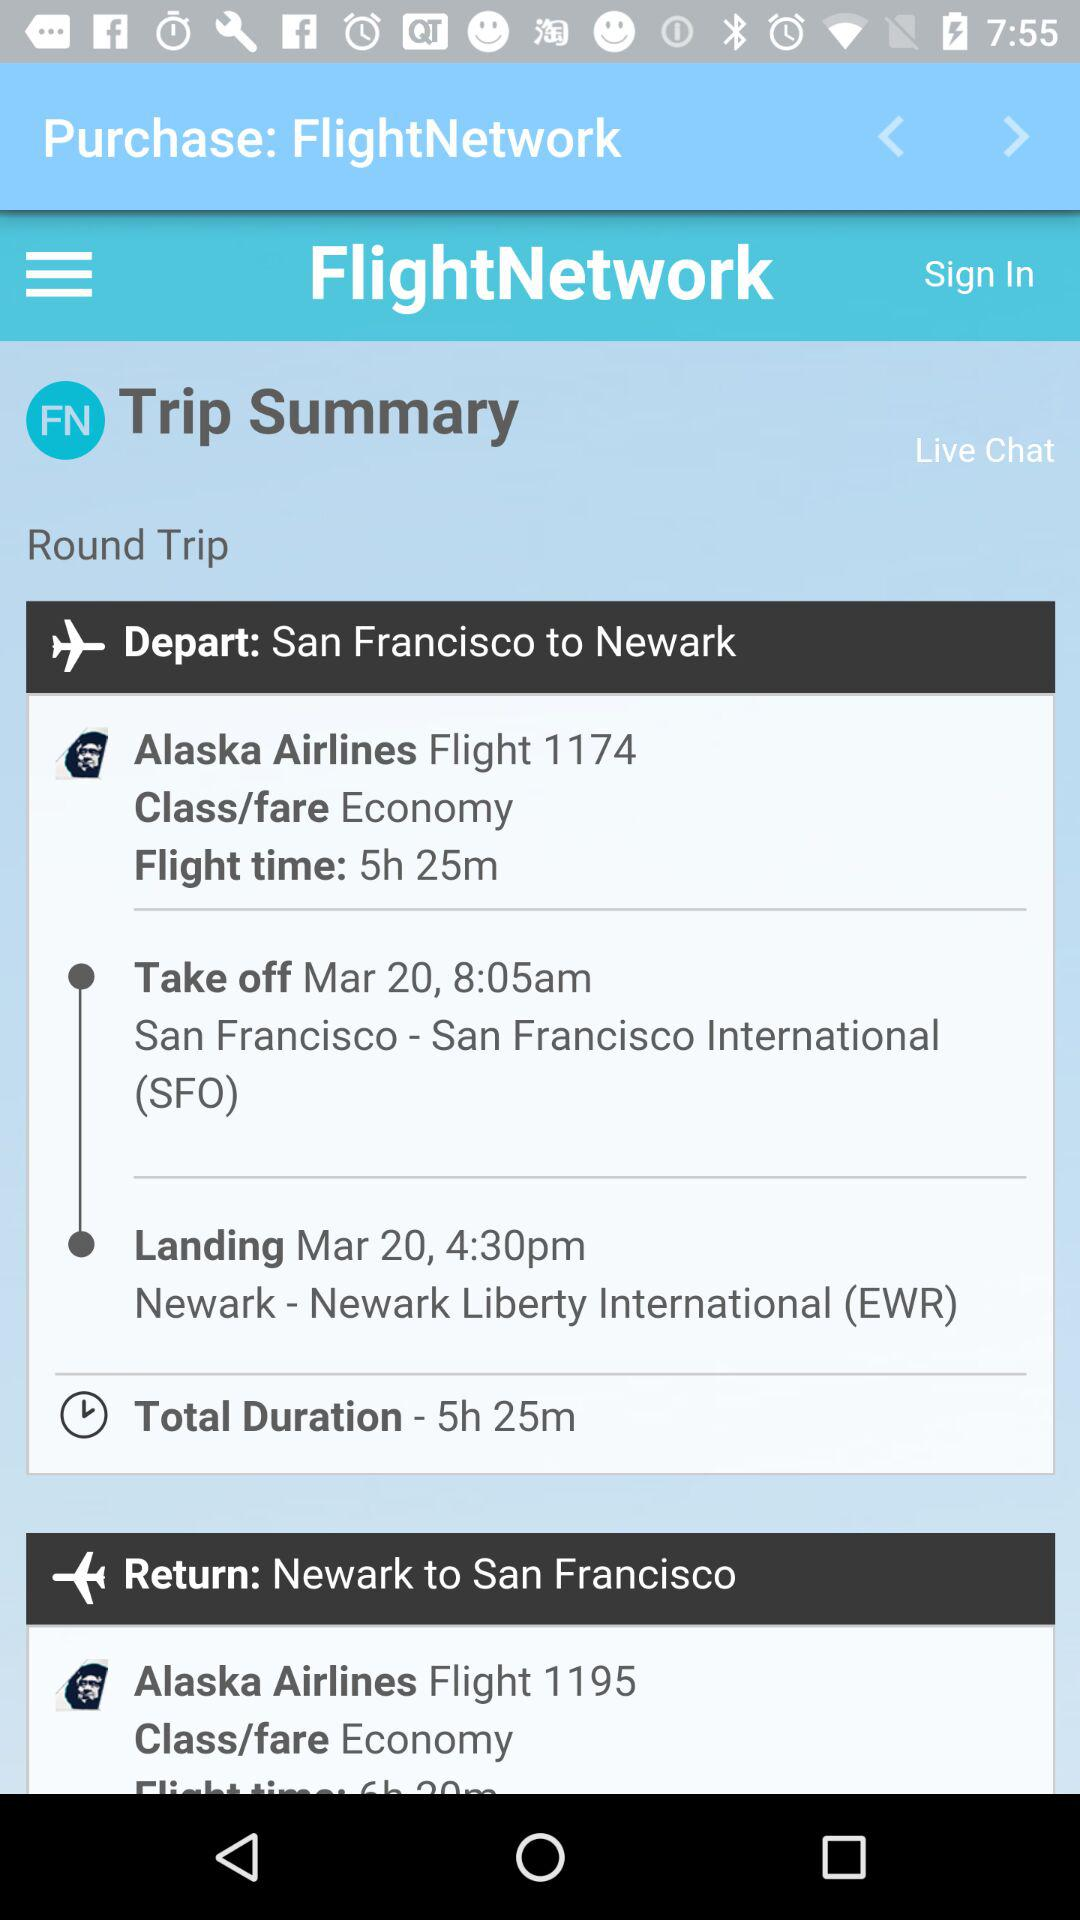What is the takeoff time of the flight from San Francisco? The takeoff time of the flight is 8:05 AM. 